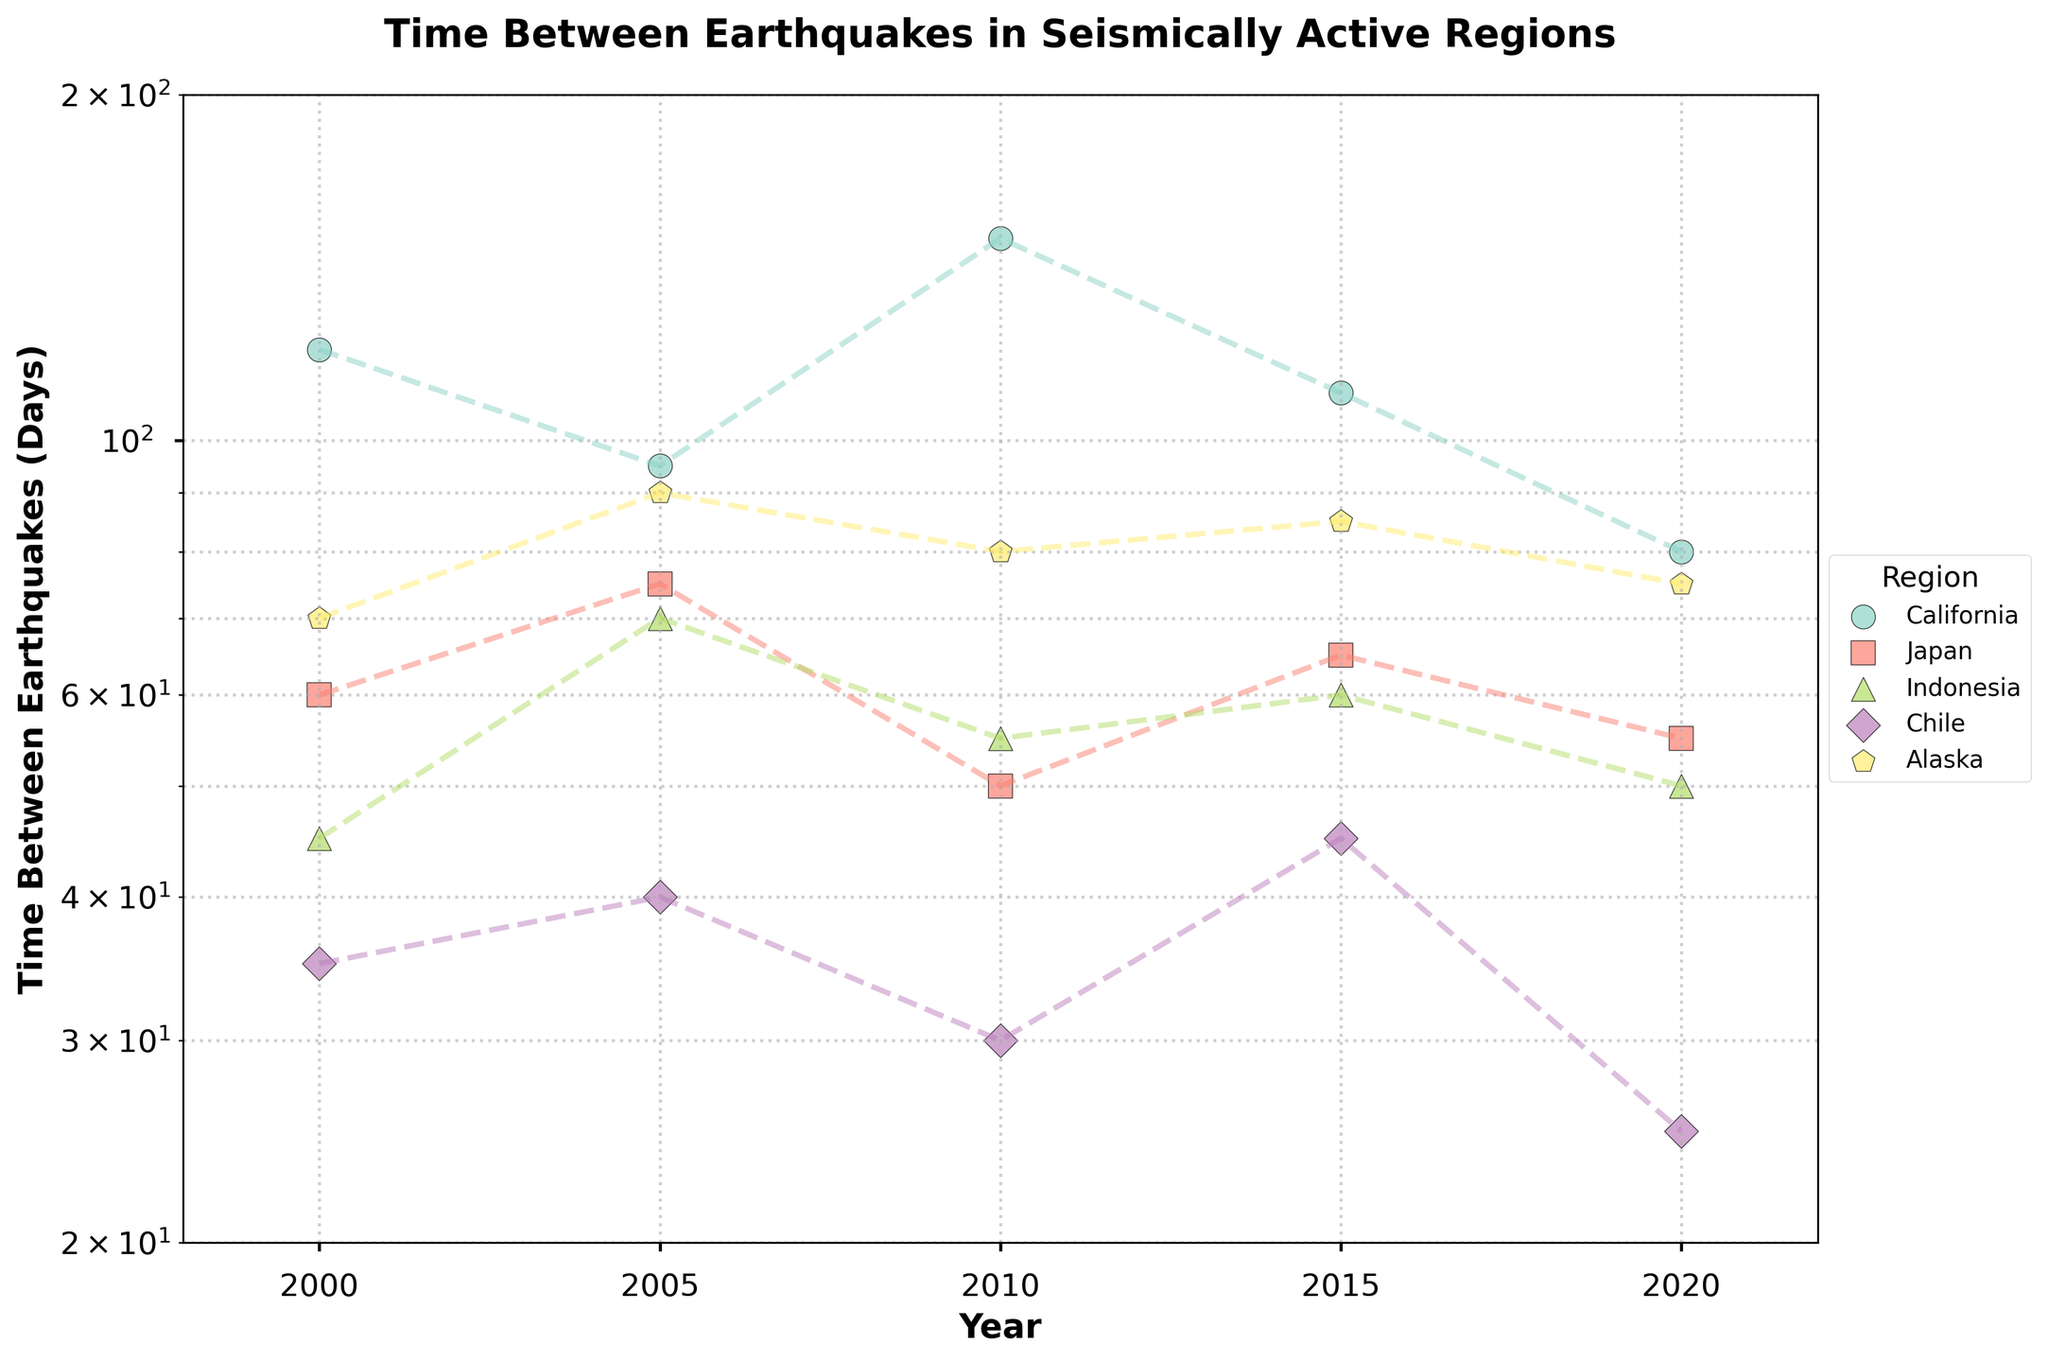What is the title of the figure? The title is printed at the top of the figure and reads "Time Between Earthquakes in Seismically Active Regions."
Answer: Time Between Earthquakes in Seismically Active Regions In which year did Chile have the shortest time between earthquakes? By locating the data points for Chile on the plot, the lowest y-value for Chile corresponds to the year 2020.
Answer: 2020 How many different regions are represented in the figure? The legend on the right of the plot lists all the regions, which are California, Japan, Indonesia, Chile, and Alaska.
Answer: 5 What is the time between earthquakes in Japan for the year 2010? By identifying the data point for Japan in 2010 on the plot, we can see it corresponds to a y-value of 50 days.
Answer: 50 days Which region had the largest decrease in the time between earthquakes from 2010 to 2020? Comparing the time between earthquakes from 2010 to 2020 for each region, Chile shows the largest decrease, from 30 days to 25 days.
Answer: Chile What is the range of the y-axis on the plot? The plot’s y-axis range is determined by its limits, which are set from 20 days to 200 days.
Answer: 20 to 200 days In what year did California have the highest time between earthquakes, and what was it? The highest y-value for California on the plot is marked in the year 2010, and it is 150 days.
Answer: 2010, 150 days Which region has the most linear trend over the years? By observing the plot, the region whose data points form a near-linear trend over the years is Chile.
Answer: Chile For which region did the time between earthquakes stay relatively stable from 2000 to 2020? By evaluating the plot, the region with the most stable y-values over time is Alaska.
Answer: Alaska What is the average time between earthquakes in Indonesia for the years 2000, 2005, and 2010? By adding the time between earthquakes for these years (45 + 70 + 55) and dividing by 3, the average is (45 + 70 + 55) / 3 = 56.67.
Answer: 56.67 days 